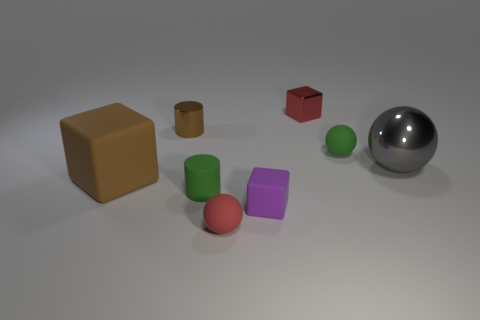The big brown thing has what shape?
Your answer should be compact. Cube. How many other objects are there of the same shape as the small brown shiny object?
Provide a succinct answer. 1. What is the color of the small object in front of the tiny purple matte thing?
Ensure brevity in your answer.  Red. Does the brown cylinder have the same material as the large gray object?
Keep it short and to the point. Yes. What number of objects are purple objects or small rubber things to the left of the green ball?
Ensure brevity in your answer.  3. There is a rubber object that is the same color as the small shiny block; what is its size?
Offer a very short reply. Small. The large object to the right of the tiny rubber cylinder has what shape?
Offer a very short reply. Sphere. Is the color of the rubber sphere that is in front of the large brown block the same as the shiny block?
Offer a terse response. Yes. There is a object that is the same color as the tiny matte cylinder; what is it made of?
Offer a terse response. Rubber. There is a sphere in front of the green matte cylinder; is it the same size as the large ball?
Your answer should be compact. No. 